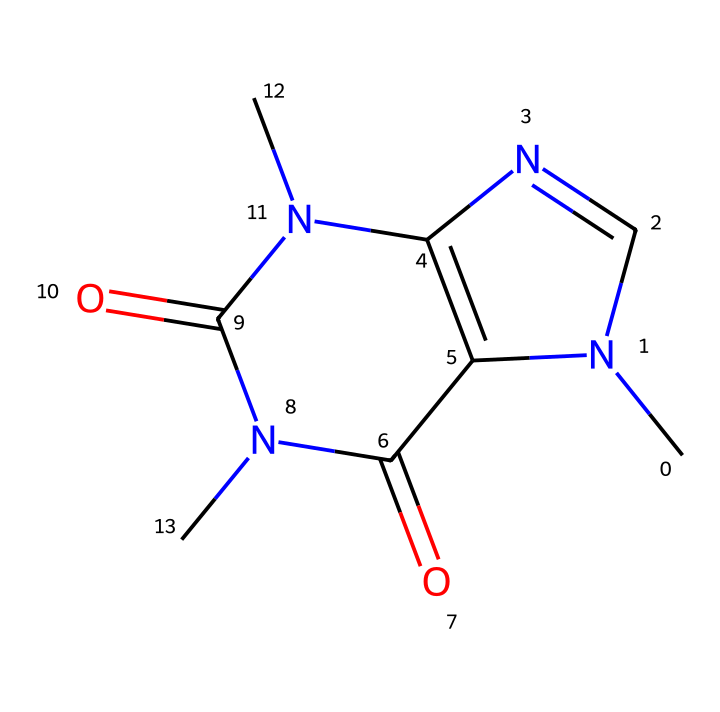What is the molecular formula of caffeine? To determine the molecular formula from the SMILES representation, we need to identify the specific atoms. The SMILES shows carbon (C), nitrogen (N), and oxygen (O) atoms. Counting these gives: Carbon - 8, Nitrogen - 4, Oxygen - 2. Thus, the molecular formula is C8H10N4O2.
Answer: C8H10N4O2 How many nitrogen atoms are present in caffeine? From the SMILES representation, we can count the nitrogen atoms. The SMILES shows a total of 4 nitrogen (N) symbols.
Answer: 4 What type of structure does caffeine represent? Caffeine is an alkaloid compound, which is characterized by the presence of nitrogen atoms in a heterocyclic structure. The nitrogen atoms give caffeine a distinct biological activity.
Answer: alkaloid What is the total number of rings present in the caffeine structure? Looking at the SMILES, we observe that caffeine has two cyclic structures; the 'N1' and 'C2' denote ring formations. Thus, there are two rings.
Answer: 2 How many carbon atoms are directly bonded to nitrogen atoms in caffeine? In the structure, we need to look for carbon atoms that are adjacent to nitrogen atoms. There are a total of 5 carbon atoms that have direct bonds with nitrogen atoms in the structure.
Answer: 5 What functional groups are present in caffeine? Analyzing the structure shows functional groups indicative of amides and nitriles due to the presence of nitrogen and carbonyl (C=O) features. Specifically, we can identify amide functional groups amongst the nitrogen atoms.
Answer: amide 